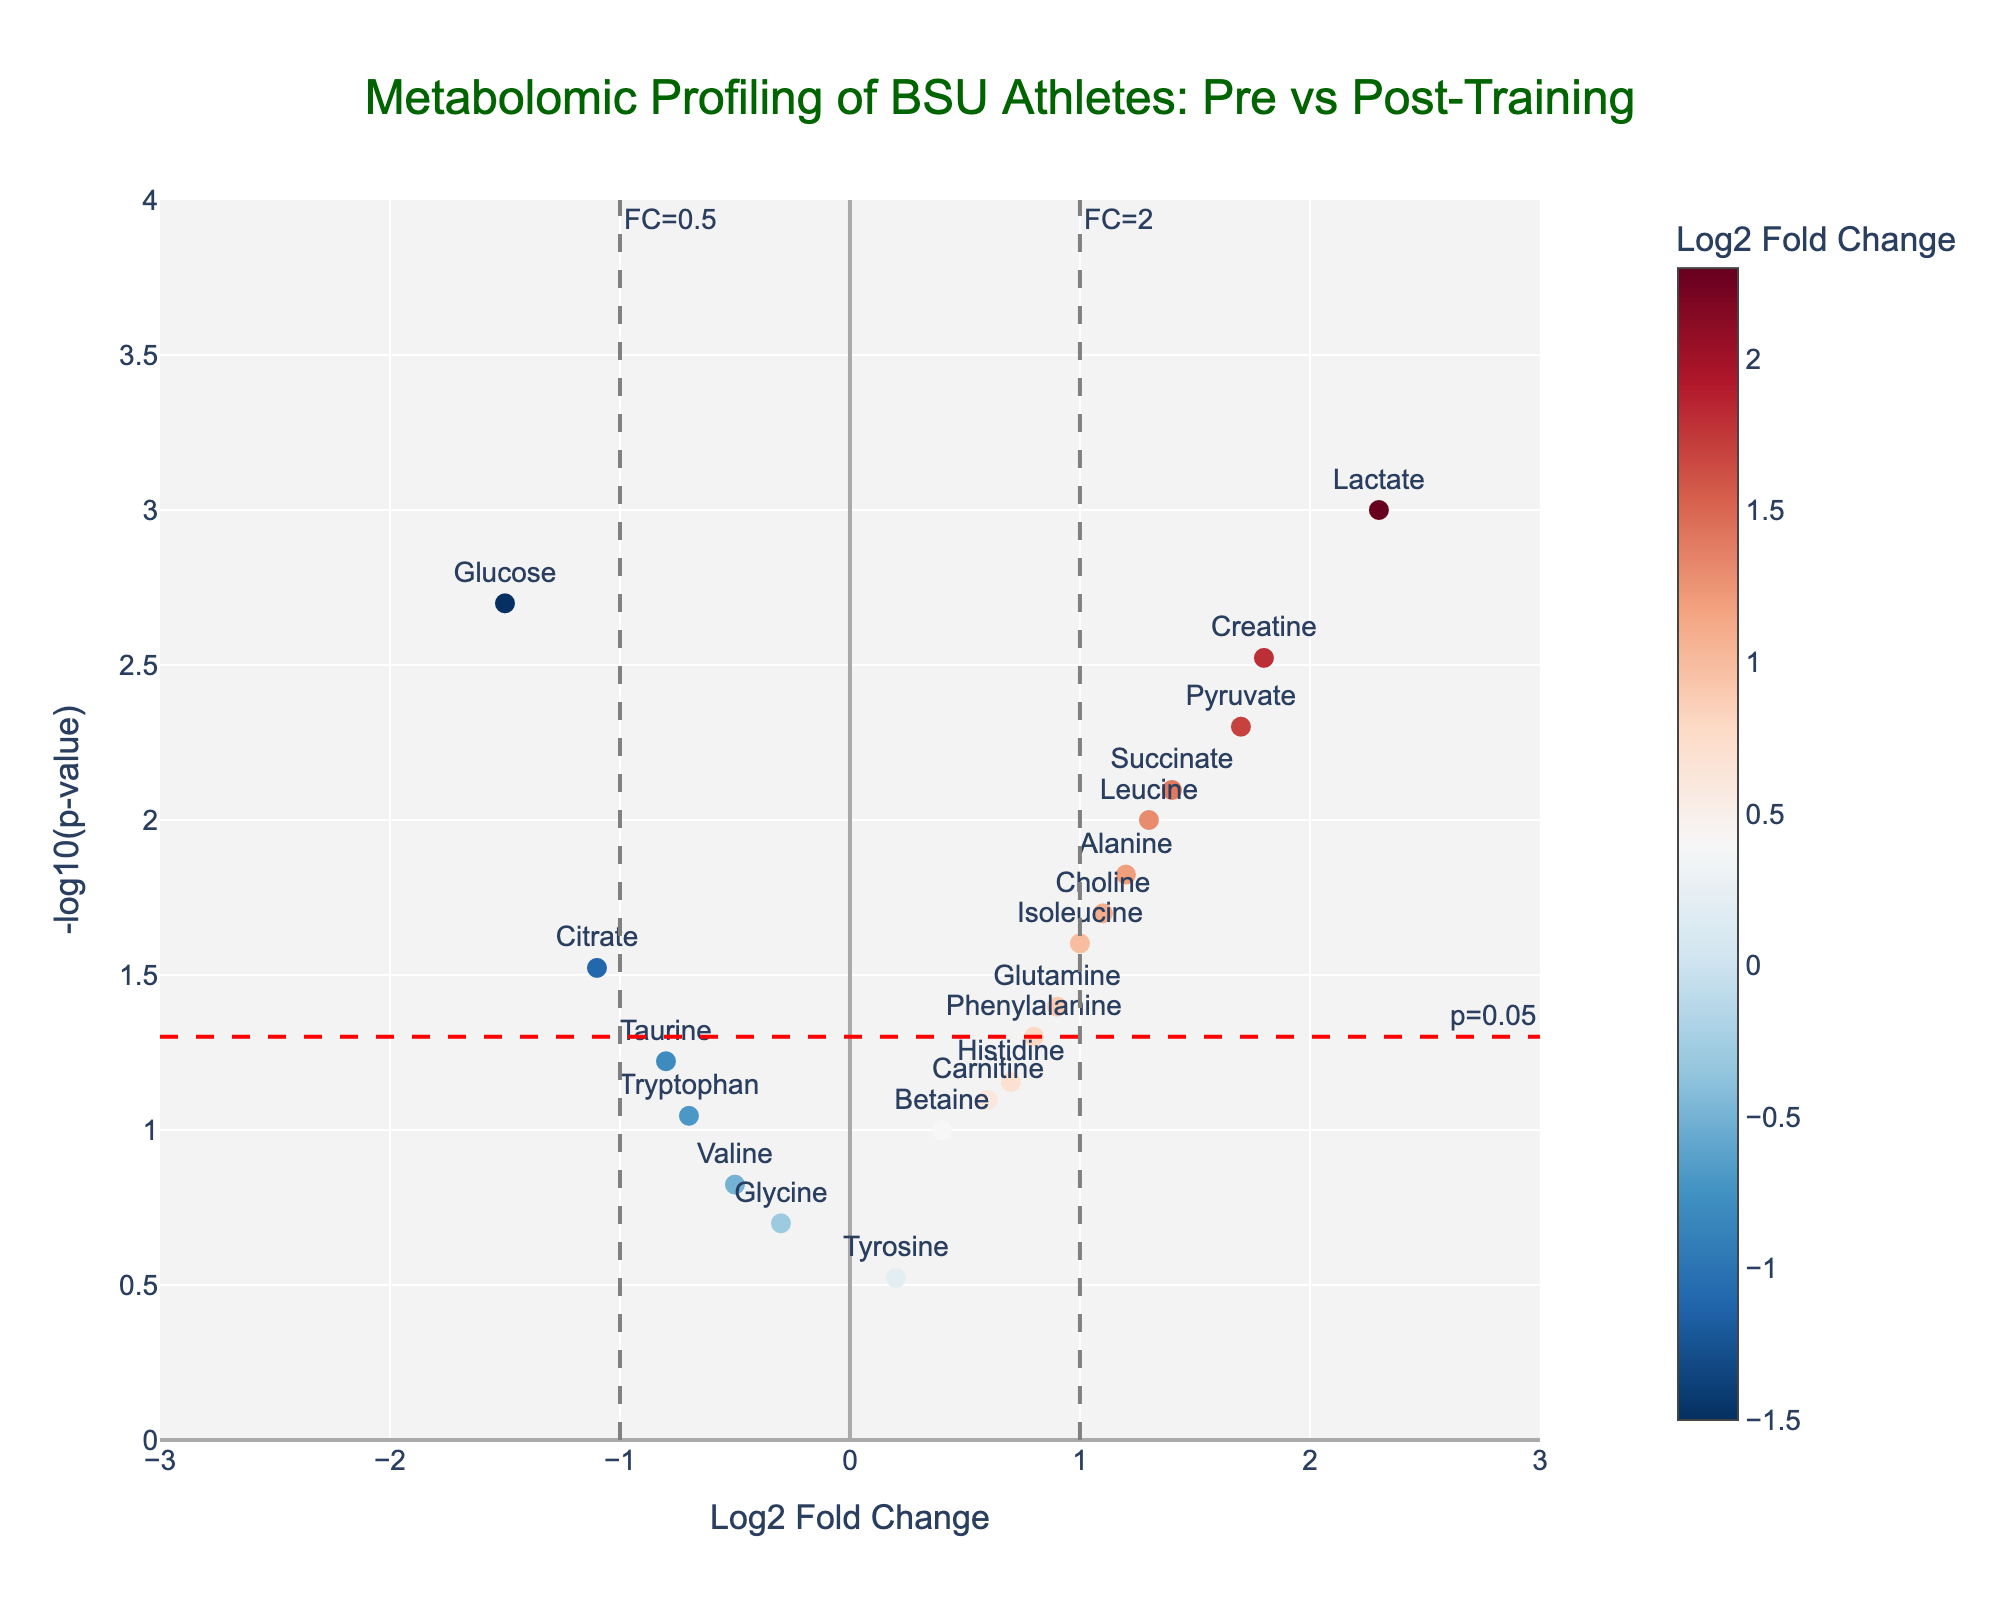How strong is the relationship between the title of the chart and BSU? The title of the chart is "Metabolomic Profiling of BSU Athletes: Pre vs Post-Training", which highlights that BSU athletes are the subject of the analysis and the focus is on their metabolomic profiling in two states (pre and post-training).
Answer: Very strong What is the fold change threshold indicated by the vertical lines? The vertical lines are labeled with fold change thresholds of 0.5 (Log2FC = -1) and 2 (Log2FC = 1).
Answer: 0.5 and 2 Which metabolite shows the highest log2 fold change? By looking at the x-axis, Lactate has the highest positive log2 fold change, which is 2.3.
Answer: Lactate How many metabolites have a p-value of less than 0.05? We count the number of points above the horizontal red dashed line labeled "p=0.05", which represent the metabolites with p-values less than 0.05. There are 10 such metabolites (Lactate, Creatine, Glucose, Alanine, Pyruvate, Choline, Succinate, Citrate, Leucine, and Isoleucine).
Answer: 10 Which metabolites have a log2 fold change lower than -1? By examining the left side of the vertical line at Log2FC = -1, Glucose and Citrate are the metabolites with log2 fold change lower than -1.
Answer: Glucose and Citrate How many metabolites show a log2 fold change greater than 1? The metabolites on the right side of the vertical line at Log2FC = 1 are Lactate, Creatine, Pyruvate, Leucine, and Succinate, totaling 5 metabolites.
Answer: 5 What is the p-value of the metabolite with a log2 fold change closest to zero? Tyrosine has the log2 fold change closest to zero with a value of 0.2 and its p-value is 0.3.
Answer: 0.3 Which metabolite shows the smallest p-value? Lactate has the smallest p-value as indicated by the highest point on the y-axis (-log10(p-value)).
Answer: Lactate Compare the fold changes of Alanine and Phenylalanine. Which one is higher? Alanine has a log2 fold change of 1.2 while Phenylalanine has a log2 fold change of 0.8. Therefore, Alanine has the higher fold change.
Answer: Alanine Which metabolite shows a significant decrease in concentration post-training? A significant decrease is indicated by a p-value less than 0.05 and a negative log2 fold change. Glucose shows a significant decrease with a Log2FC of -1.5 and a p-value of 0.002.
Answer: Glucose 